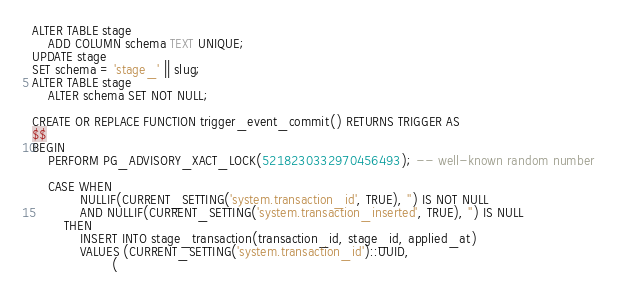Convert code to text. <code><loc_0><loc_0><loc_500><loc_500><_SQL_>ALTER TABLE stage
	ADD COLUMN schema TEXT UNIQUE;
UPDATE stage
SET schema = 'stage_' || slug;
ALTER TABLE stage
	ALTER schema SET NOT NULL;

CREATE OR REPLACE FUNCTION trigger_event_commit() RETURNS TRIGGER AS
$$
BEGIN
	PERFORM PG_ADVISORY_XACT_LOCK(5218230332970456493); -- well-known random number

	CASE WHEN
			NULLIF(CURRENT_SETTING('system.transaction_id', TRUE), '') IS NOT NULL
			AND NULLIF(CURRENT_SETTING('system.transaction_inserted', TRUE), '') IS NULL
		THEN
			INSERT INTO stage_transaction(transaction_id, stage_id, applied_at)
			VALUES (CURRENT_SETTING('system.transaction_id')::UUID,
					(</code> 